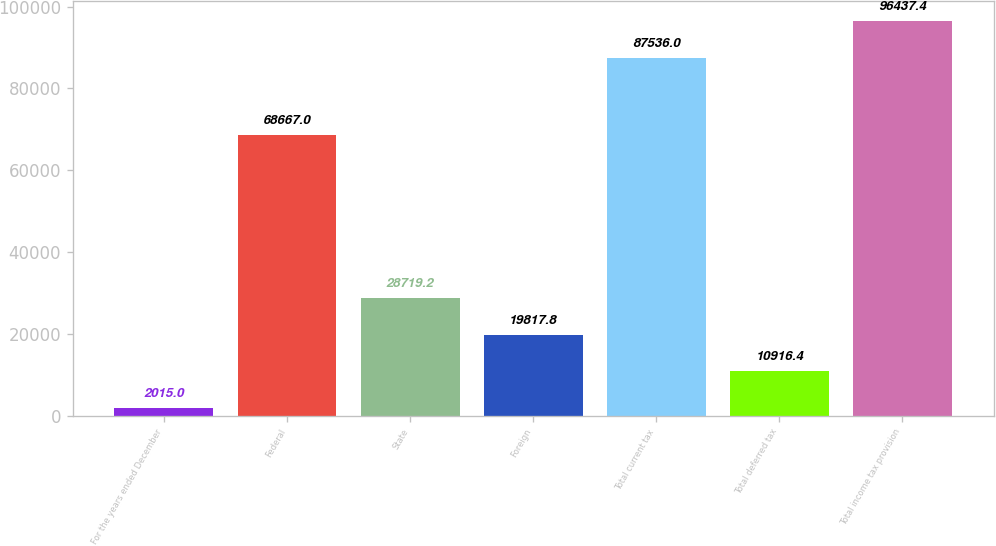Convert chart. <chart><loc_0><loc_0><loc_500><loc_500><bar_chart><fcel>For the years ended December<fcel>Federal<fcel>State<fcel>Foreign<fcel>Total current tax<fcel>Total deferred tax<fcel>Total income tax provision<nl><fcel>2015<fcel>68667<fcel>28719.2<fcel>19817.8<fcel>87536<fcel>10916.4<fcel>96437.4<nl></chart> 